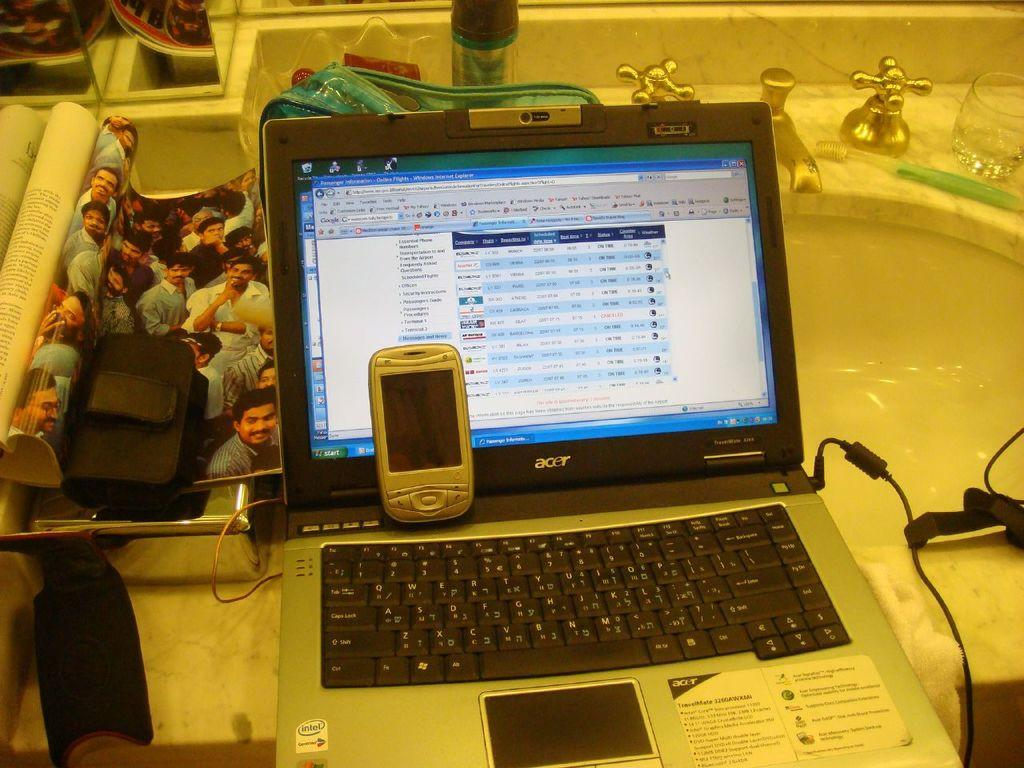<image>
Give a short and clear explanation of the subsequent image. an open laptop with the brand acer written on the monitor. 